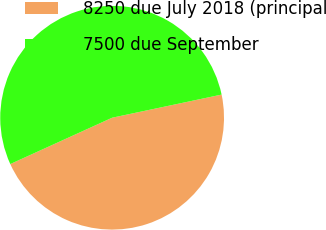<chart> <loc_0><loc_0><loc_500><loc_500><pie_chart><fcel>8250 due July 2018 (principal<fcel>7500 due September<nl><fcel>46.52%<fcel>53.48%<nl></chart> 